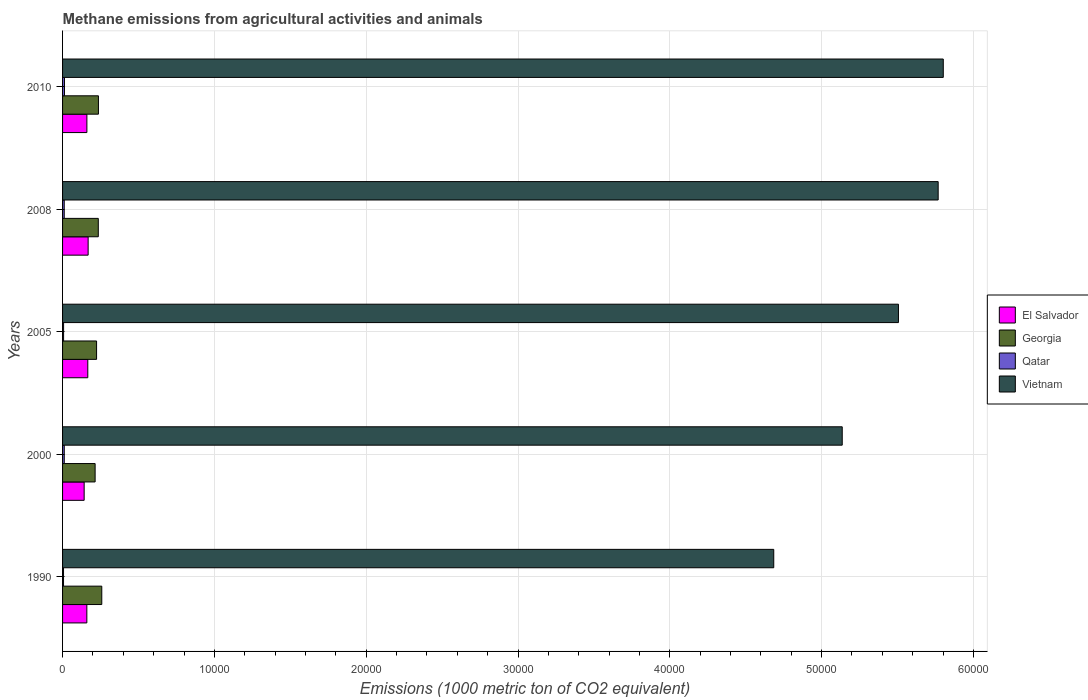Are the number of bars per tick equal to the number of legend labels?
Provide a succinct answer. Yes. In how many cases, is the number of bars for a given year not equal to the number of legend labels?
Provide a short and direct response. 0. What is the amount of methane emitted in Vietnam in 2005?
Provide a succinct answer. 5.51e+04. Across all years, what is the maximum amount of methane emitted in El Salvador?
Keep it short and to the point. 1684.6. Across all years, what is the minimum amount of methane emitted in El Salvador?
Your answer should be very brief. 1421.9. What is the total amount of methane emitted in Georgia in the graph?
Offer a terse response. 1.17e+04. What is the difference between the amount of methane emitted in El Salvador in 2005 and that in 2010?
Give a very brief answer. 60.1. What is the difference between the amount of methane emitted in Vietnam in 1990 and the amount of methane emitted in El Salvador in 2008?
Offer a very short reply. 4.52e+04. What is the average amount of methane emitted in Vietnam per year?
Provide a short and direct response. 5.38e+04. In the year 2008, what is the difference between the amount of methane emitted in Vietnam and amount of methane emitted in El Salvador?
Keep it short and to the point. 5.60e+04. In how many years, is the amount of methane emitted in Georgia greater than 24000 1000 metric ton?
Offer a terse response. 0. What is the ratio of the amount of methane emitted in Georgia in 2005 to that in 2008?
Keep it short and to the point. 0.95. What is the difference between the highest and the second highest amount of methane emitted in El Salvador?
Provide a short and direct response. 22.5. What is the difference between the highest and the lowest amount of methane emitted in Qatar?
Your answer should be compact. 62.1. In how many years, is the amount of methane emitted in El Salvador greater than the average amount of methane emitted in El Salvador taken over all years?
Ensure brevity in your answer.  4. Is the sum of the amount of methane emitted in Vietnam in 1990 and 2000 greater than the maximum amount of methane emitted in El Salvador across all years?
Offer a terse response. Yes. What does the 4th bar from the top in 2000 represents?
Make the answer very short. El Salvador. What does the 2nd bar from the bottom in 1990 represents?
Make the answer very short. Georgia. How many bars are there?
Give a very brief answer. 20. How many years are there in the graph?
Provide a short and direct response. 5. What is the difference between two consecutive major ticks on the X-axis?
Offer a very short reply. 10000. Are the values on the major ticks of X-axis written in scientific E-notation?
Make the answer very short. No. Where does the legend appear in the graph?
Provide a succinct answer. Center right. How are the legend labels stacked?
Your answer should be compact. Vertical. What is the title of the graph?
Ensure brevity in your answer.  Methane emissions from agricultural activities and animals. Does "Eritrea" appear as one of the legend labels in the graph?
Your answer should be compact. No. What is the label or title of the X-axis?
Provide a succinct answer. Emissions (1000 metric ton of CO2 equivalent). What is the label or title of the Y-axis?
Offer a terse response. Years. What is the Emissions (1000 metric ton of CO2 equivalent) of El Salvador in 1990?
Your answer should be compact. 1599.5. What is the Emissions (1000 metric ton of CO2 equivalent) in Georgia in 1990?
Your answer should be compact. 2583.7. What is the Emissions (1000 metric ton of CO2 equivalent) of Qatar in 1990?
Your answer should be compact. 63.8. What is the Emissions (1000 metric ton of CO2 equivalent) of Vietnam in 1990?
Your answer should be compact. 4.68e+04. What is the Emissions (1000 metric ton of CO2 equivalent) in El Salvador in 2000?
Give a very brief answer. 1421.9. What is the Emissions (1000 metric ton of CO2 equivalent) in Georgia in 2000?
Your answer should be compact. 2145. What is the Emissions (1000 metric ton of CO2 equivalent) in Qatar in 2000?
Make the answer very short. 111.5. What is the Emissions (1000 metric ton of CO2 equivalent) of Vietnam in 2000?
Ensure brevity in your answer.  5.14e+04. What is the Emissions (1000 metric ton of CO2 equivalent) in El Salvador in 2005?
Your response must be concise. 1662.1. What is the Emissions (1000 metric ton of CO2 equivalent) in Georgia in 2005?
Your response must be concise. 2240.7. What is the Emissions (1000 metric ton of CO2 equivalent) in Qatar in 2005?
Your response must be concise. 67.4. What is the Emissions (1000 metric ton of CO2 equivalent) of Vietnam in 2005?
Your response must be concise. 5.51e+04. What is the Emissions (1000 metric ton of CO2 equivalent) of El Salvador in 2008?
Offer a terse response. 1684.6. What is the Emissions (1000 metric ton of CO2 equivalent) in Georgia in 2008?
Your answer should be compact. 2354. What is the Emissions (1000 metric ton of CO2 equivalent) in Qatar in 2008?
Keep it short and to the point. 110. What is the Emissions (1000 metric ton of CO2 equivalent) of Vietnam in 2008?
Your response must be concise. 5.77e+04. What is the Emissions (1000 metric ton of CO2 equivalent) of El Salvador in 2010?
Your answer should be compact. 1602. What is the Emissions (1000 metric ton of CO2 equivalent) of Georgia in 2010?
Your answer should be compact. 2363.1. What is the Emissions (1000 metric ton of CO2 equivalent) of Qatar in 2010?
Offer a terse response. 125.9. What is the Emissions (1000 metric ton of CO2 equivalent) in Vietnam in 2010?
Your answer should be compact. 5.80e+04. Across all years, what is the maximum Emissions (1000 metric ton of CO2 equivalent) of El Salvador?
Keep it short and to the point. 1684.6. Across all years, what is the maximum Emissions (1000 metric ton of CO2 equivalent) of Georgia?
Your answer should be compact. 2583.7. Across all years, what is the maximum Emissions (1000 metric ton of CO2 equivalent) in Qatar?
Offer a very short reply. 125.9. Across all years, what is the maximum Emissions (1000 metric ton of CO2 equivalent) in Vietnam?
Make the answer very short. 5.80e+04. Across all years, what is the minimum Emissions (1000 metric ton of CO2 equivalent) of El Salvador?
Ensure brevity in your answer.  1421.9. Across all years, what is the minimum Emissions (1000 metric ton of CO2 equivalent) of Georgia?
Provide a short and direct response. 2145. Across all years, what is the minimum Emissions (1000 metric ton of CO2 equivalent) in Qatar?
Keep it short and to the point. 63.8. Across all years, what is the minimum Emissions (1000 metric ton of CO2 equivalent) in Vietnam?
Offer a terse response. 4.68e+04. What is the total Emissions (1000 metric ton of CO2 equivalent) in El Salvador in the graph?
Your answer should be very brief. 7970.1. What is the total Emissions (1000 metric ton of CO2 equivalent) of Georgia in the graph?
Keep it short and to the point. 1.17e+04. What is the total Emissions (1000 metric ton of CO2 equivalent) of Qatar in the graph?
Offer a terse response. 478.6. What is the total Emissions (1000 metric ton of CO2 equivalent) in Vietnam in the graph?
Your answer should be compact. 2.69e+05. What is the difference between the Emissions (1000 metric ton of CO2 equivalent) of El Salvador in 1990 and that in 2000?
Provide a short and direct response. 177.6. What is the difference between the Emissions (1000 metric ton of CO2 equivalent) in Georgia in 1990 and that in 2000?
Provide a succinct answer. 438.7. What is the difference between the Emissions (1000 metric ton of CO2 equivalent) of Qatar in 1990 and that in 2000?
Your answer should be compact. -47.7. What is the difference between the Emissions (1000 metric ton of CO2 equivalent) of Vietnam in 1990 and that in 2000?
Provide a succinct answer. -4511. What is the difference between the Emissions (1000 metric ton of CO2 equivalent) in El Salvador in 1990 and that in 2005?
Your response must be concise. -62.6. What is the difference between the Emissions (1000 metric ton of CO2 equivalent) in Georgia in 1990 and that in 2005?
Make the answer very short. 343. What is the difference between the Emissions (1000 metric ton of CO2 equivalent) in Qatar in 1990 and that in 2005?
Provide a succinct answer. -3.6. What is the difference between the Emissions (1000 metric ton of CO2 equivalent) in Vietnam in 1990 and that in 2005?
Make the answer very short. -8213.9. What is the difference between the Emissions (1000 metric ton of CO2 equivalent) in El Salvador in 1990 and that in 2008?
Ensure brevity in your answer.  -85.1. What is the difference between the Emissions (1000 metric ton of CO2 equivalent) of Georgia in 1990 and that in 2008?
Your response must be concise. 229.7. What is the difference between the Emissions (1000 metric ton of CO2 equivalent) in Qatar in 1990 and that in 2008?
Offer a terse response. -46.2. What is the difference between the Emissions (1000 metric ton of CO2 equivalent) of Vietnam in 1990 and that in 2008?
Ensure brevity in your answer.  -1.08e+04. What is the difference between the Emissions (1000 metric ton of CO2 equivalent) in Georgia in 1990 and that in 2010?
Offer a terse response. 220.6. What is the difference between the Emissions (1000 metric ton of CO2 equivalent) of Qatar in 1990 and that in 2010?
Provide a succinct answer. -62.1. What is the difference between the Emissions (1000 metric ton of CO2 equivalent) of Vietnam in 1990 and that in 2010?
Your answer should be compact. -1.12e+04. What is the difference between the Emissions (1000 metric ton of CO2 equivalent) of El Salvador in 2000 and that in 2005?
Your answer should be compact. -240.2. What is the difference between the Emissions (1000 metric ton of CO2 equivalent) of Georgia in 2000 and that in 2005?
Give a very brief answer. -95.7. What is the difference between the Emissions (1000 metric ton of CO2 equivalent) of Qatar in 2000 and that in 2005?
Give a very brief answer. 44.1. What is the difference between the Emissions (1000 metric ton of CO2 equivalent) in Vietnam in 2000 and that in 2005?
Your answer should be very brief. -3702.9. What is the difference between the Emissions (1000 metric ton of CO2 equivalent) in El Salvador in 2000 and that in 2008?
Your answer should be compact. -262.7. What is the difference between the Emissions (1000 metric ton of CO2 equivalent) in Georgia in 2000 and that in 2008?
Make the answer very short. -209. What is the difference between the Emissions (1000 metric ton of CO2 equivalent) of Qatar in 2000 and that in 2008?
Your answer should be compact. 1.5. What is the difference between the Emissions (1000 metric ton of CO2 equivalent) in Vietnam in 2000 and that in 2008?
Keep it short and to the point. -6319.4. What is the difference between the Emissions (1000 metric ton of CO2 equivalent) of El Salvador in 2000 and that in 2010?
Provide a succinct answer. -180.1. What is the difference between the Emissions (1000 metric ton of CO2 equivalent) in Georgia in 2000 and that in 2010?
Offer a terse response. -218.1. What is the difference between the Emissions (1000 metric ton of CO2 equivalent) of Qatar in 2000 and that in 2010?
Ensure brevity in your answer.  -14.4. What is the difference between the Emissions (1000 metric ton of CO2 equivalent) in Vietnam in 2000 and that in 2010?
Give a very brief answer. -6656.2. What is the difference between the Emissions (1000 metric ton of CO2 equivalent) in El Salvador in 2005 and that in 2008?
Offer a very short reply. -22.5. What is the difference between the Emissions (1000 metric ton of CO2 equivalent) of Georgia in 2005 and that in 2008?
Offer a very short reply. -113.3. What is the difference between the Emissions (1000 metric ton of CO2 equivalent) of Qatar in 2005 and that in 2008?
Give a very brief answer. -42.6. What is the difference between the Emissions (1000 metric ton of CO2 equivalent) in Vietnam in 2005 and that in 2008?
Offer a terse response. -2616.5. What is the difference between the Emissions (1000 metric ton of CO2 equivalent) in El Salvador in 2005 and that in 2010?
Make the answer very short. 60.1. What is the difference between the Emissions (1000 metric ton of CO2 equivalent) in Georgia in 2005 and that in 2010?
Ensure brevity in your answer.  -122.4. What is the difference between the Emissions (1000 metric ton of CO2 equivalent) in Qatar in 2005 and that in 2010?
Keep it short and to the point. -58.5. What is the difference between the Emissions (1000 metric ton of CO2 equivalent) in Vietnam in 2005 and that in 2010?
Make the answer very short. -2953.3. What is the difference between the Emissions (1000 metric ton of CO2 equivalent) in El Salvador in 2008 and that in 2010?
Offer a terse response. 82.6. What is the difference between the Emissions (1000 metric ton of CO2 equivalent) of Georgia in 2008 and that in 2010?
Offer a terse response. -9.1. What is the difference between the Emissions (1000 metric ton of CO2 equivalent) of Qatar in 2008 and that in 2010?
Provide a succinct answer. -15.9. What is the difference between the Emissions (1000 metric ton of CO2 equivalent) in Vietnam in 2008 and that in 2010?
Your answer should be compact. -336.8. What is the difference between the Emissions (1000 metric ton of CO2 equivalent) of El Salvador in 1990 and the Emissions (1000 metric ton of CO2 equivalent) of Georgia in 2000?
Offer a terse response. -545.5. What is the difference between the Emissions (1000 metric ton of CO2 equivalent) of El Salvador in 1990 and the Emissions (1000 metric ton of CO2 equivalent) of Qatar in 2000?
Your answer should be compact. 1488. What is the difference between the Emissions (1000 metric ton of CO2 equivalent) of El Salvador in 1990 and the Emissions (1000 metric ton of CO2 equivalent) of Vietnam in 2000?
Ensure brevity in your answer.  -4.98e+04. What is the difference between the Emissions (1000 metric ton of CO2 equivalent) of Georgia in 1990 and the Emissions (1000 metric ton of CO2 equivalent) of Qatar in 2000?
Keep it short and to the point. 2472.2. What is the difference between the Emissions (1000 metric ton of CO2 equivalent) of Georgia in 1990 and the Emissions (1000 metric ton of CO2 equivalent) of Vietnam in 2000?
Offer a very short reply. -4.88e+04. What is the difference between the Emissions (1000 metric ton of CO2 equivalent) in Qatar in 1990 and the Emissions (1000 metric ton of CO2 equivalent) in Vietnam in 2000?
Your response must be concise. -5.13e+04. What is the difference between the Emissions (1000 metric ton of CO2 equivalent) of El Salvador in 1990 and the Emissions (1000 metric ton of CO2 equivalent) of Georgia in 2005?
Offer a very short reply. -641.2. What is the difference between the Emissions (1000 metric ton of CO2 equivalent) in El Salvador in 1990 and the Emissions (1000 metric ton of CO2 equivalent) in Qatar in 2005?
Offer a terse response. 1532.1. What is the difference between the Emissions (1000 metric ton of CO2 equivalent) in El Salvador in 1990 and the Emissions (1000 metric ton of CO2 equivalent) in Vietnam in 2005?
Offer a very short reply. -5.35e+04. What is the difference between the Emissions (1000 metric ton of CO2 equivalent) of Georgia in 1990 and the Emissions (1000 metric ton of CO2 equivalent) of Qatar in 2005?
Ensure brevity in your answer.  2516.3. What is the difference between the Emissions (1000 metric ton of CO2 equivalent) in Georgia in 1990 and the Emissions (1000 metric ton of CO2 equivalent) in Vietnam in 2005?
Provide a short and direct response. -5.25e+04. What is the difference between the Emissions (1000 metric ton of CO2 equivalent) in Qatar in 1990 and the Emissions (1000 metric ton of CO2 equivalent) in Vietnam in 2005?
Provide a succinct answer. -5.50e+04. What is the difference between the Emissions (1000 metric ton of CO2 equivalent) of El Salvador in 1990 and the Emissions (1000 metric ton of CO2 equivalent) of Georgia in 2008?
Your response must be concise. -754.5. What is the difference between the Emissions (1000 metric ton of CO2 equivalent) in El Salvador in 1990 and the Emissions (1000 metric ton of CO2 equivalent) in Qatar in 2008?
Offer a very short reply. 1489.5. What is the difference between the Emissions (1000 metric ton of CO2 equivalent) in El Salvador in 1990 and the Emissions (1000 metric ton of CO2 equivalent) in Vietnam in 2008?
Make the answer very short. -5.61e+04. What is the difference between the Emissions (1000 metric ton of CO2 equivalent) of Georgia in 1990 and the Emissions (1000 metric ton of CO2 equivalent) of Qatar in 2008?
Offer a terse response. 2473.7. What is the difference between the Emissions (1000 metric ton of CO2 equivalent) in Georgia in 1990 and the Emissions (1000 metric ton of CO2 equivalent) in Vietnam in 2008?
Make the answer very short. -5.51e+04. What is the difference between the Emissions (1000 metric ton of CO2 equivalent) of Qatar in 1990 and the Emissions (1000 metric ton of CO2 equivalent) of Vietnam in 2008?
Make the answer very short. -5.76e+04. What is the difference between the Emissions (1000 metric ton of CO2 equivalent) in El Salvador in 1990 and the Emissions (1000 metric ton of CO2 equivalent) in Georgia in 2010?
Make the answer very short. -763.6. What is the difference between the Emissions (1000 metric ton of CO2 equivalent) of El Salvador in 1990 and the Emissions (1000 metric ton of CO2 equivalent) of Qatar in 2010?
Ensure brevity in your answer.  1473.6. What is the difference between the Emissions (1000 metric ton of CO2 equivalent) in El Salvador in 1990 and the Emissions (1000 metric ton of CO2 equivalent) in Vietnam in 2010?
Make the answer very short. -5.64e+04. What is the difference between the Emissions (1000 metric ton of CO2 equivalent) of Georgia in 1990 and the Emissions (1000 metric ton of CO2 equivalent) of Qatar in 2010?
Ensure brevity in your answer.  2457.8. What is the difference between the Emissions (1000 metric ton of CO2 equivalent) in Georgia in 1990 and the Emissions (1000 metric ton of CO2 equivalent) in Vietnam in 2010?
Provide a succinct answer. -5.54e+04. What is the difference between the Emissions (1000 metric ton of CO2 equivalent) in Qatar in 1990 and the Emissions (1000 metric ton of CO2 equivalent) in Vietnam in 2010?
Provide a succinct answer. -5.80e+04. What is the difference between the Emissions (1000 metric ton of CO2 equivalent) in El Salvador in 2000 and the Emissions (1000 metric ton of CO2 equivalent) in Georgia in 2005?
Offer a terse response. -818.8. What is the difference between the Emissions (1000 metric ton of CO2 equivalent) of El Salvador in 2000 and the Emissions (1000 metric ton of CO2 equivalent) of Qatar in 2005?
Give a very brief answer. 1354.5. What is the difference between the Emissions (1000 metric ton of CO2 equivalent) in El Salvador in 2000 and the Emissions (1000 metric ton of CO2 equivalent) in Vietnam in 2005?
Offer a terse response. -5.36e+04. What is the difference between the Emissions (1000 metric ton of CO2 equivalent) in Georgia in 2000 and the Emissions (1000 metric ton of CO2 equivalent) in Qatar in 2005?
Give a very brief answer. 2077.6. What is the difference between the Emissions (1000 metric ton of CO2 equivalent) in Georgia in 2000 and the Emissions (1000 metric ton of CO2 equivalent) in Vietnam in 2005?
Provide a short and direct response. -5.29e+04. What is the difference between the Emissions (1000 metric ton of CO2 equivalent) of Qatar in 2000 and the Emissions (1000 metric ton of CO2 equivalent) of Vietnam in 2005?
Provide a short and direct response. -5.50e+04. What is the difference between the Emissions (1000 metric ton of CO2 equivalent) in El Salvador in 2000 and the Emissions (1000 metric ton of CO2 equivalent) in Georgia in 2008?
Keep it short and to the point. -932.1. What is the difference between the Emissions (1000 metric ton of CO2 equivalent) of El Salvador in 2000 and the Emissions (1000 metric ton of CO2 equivalent) of Qatar in 2008?
Your answer should be compact. 1311.9. What is the difference between the Emissions (1000 metric ton of CO2 equivalent) in El Salvador in 2000 and the Emissions (1000 metric ton of CO2 equivalent) in Vietnam in 2008?
Provide a short and direct response. -5.63e+04. What is the difference between the Emissions (1000 metric ton of CO2 equivalent) in Georgia in 2000 and the Emissions (1000 metric ton of CO2 equivalent) in Qatar in 2008?
Give a very brief answer. 2035. What is the difference between the Emissions (1000 metric ton of CO2 equivalent) in Georgia in 2000 and the Emissions (1000 metric ton of CO2 equivalent) in Vietnam in 2008?
Offer a very short reply. -5.55e+04. What is the difference between the Emissions (1000 metric ton of CO2 equivalent) in Qatar in 2000 and the Emissions (1000 metric ton of CO2 equivalent) in Vietnam in 2008?
Give a very brief answer. -5.76e+04. What is the difference between the Emissions (1000 metric ton of CO2 equivalent) of El Salvador in 2000 and the Emissions (1000 metric ton of CO2 equivalent) of Georgia in 2010?
Your answer should be compact. -941.2. What is the difference between the Emissions (1000 metric ton of CO2 equivalent) in El Salvador in 2000 and the Emissions (1000 metric ton of CO2 equivalent) in Qatar in 2010?
Offer a terse response. 1296. What is the difference between the Emissions (1000 metric ton of CO2 equivalent) in El Salvador in 2000 and the Emissions (1000 metric ton of CO2 equivalent) in Vietnam in 2010?
Ensure brevity in your answer.  -5.66e+04. What is the difference between the Emissions (1000 metric ton of CO2 equivalent) of Georgia in 2000 and the Emissions (1000 metric ton of CO2 equivalent) of Qatar in 2010?
Your answer should be very brief. 2019.1. What is the difference between the Emissions (1000 metric ton of CO2 equivalent) in Georgia in 2000 and the Emissions (1000 metric ton of CO2 equivalent) in Vietnam in 2010?
Provide a short and direct response. -5.59e+04. What is the difference between the Emissions (1000 metric ton of CO2 equivalent) in Qatar in 2000 and the Emissions (1000 metric ton of CO2 equivalent) in Vietnam in 2010?
Make the answer very short. -5.79e+04. What is the difference between the Emissions (1000 metric ton of CO2 equivalent) of El Salvador in 2005 and the Emissions (1000 metric ton of CO2 equivalent) of Georgia in 2008?
Provide a succinct answer. -691.9. What is the difference between the Emissions (1000 metric ton of CO2 equivalent) of El Salvador in 2005 and the Emissions (1000 metric ton of CO2 equivalent) of Qatar in 2008?
Keep it short and to the point. 1552.1. What is the difference between the Emissions (1000 metric ton of CO2 equivalent) of El Salvador in 2005 and the Emissions (1000 metric ton of CO2 equivalent) of Vietnam in 2008?
Your response must be concise. -5.60e+04. What is the difference between the Emissions (1000 metric ton of CO2 equivalent) in Georgia in 2005 and the Emissions (1000 metric ton of CO2 equivalent) in Qatar in 2008?
Keep it short and to the point. 2130.7. What is the difference between the Emissions (1000 metric ton of CO2 equivalent) in Georgia in 2005 and the Emissions (1000 metric ton of CO2 equivalent) in Vietnam in 2008?
Offer a very short reply. -5.54e+04. What is the difference between the Emissions (1000 metric ton of CO2 equivalent) of Qatar in 2005 and the Emissions (1000 metric ton of CO2 equivalent) of Vietnam in 2008?
Offer a very short reply. -5.76e+04. What is the difference between the Emissions (1000 metric ton of CO2 equivalent) of El Salvador in 2005 and the Emissions (1000 metric ton of CO2 equivalent) of Georgia in 2010?
Offer a terse response. -701. What is the difference between the Emissions (1000 metric ton of CO2 equivalent) of El Salvador in 2005 and the Emissions (1000 metric ton of CO2 equivalent) of Qatar in 2010?
Your answer should be very brief. 1536.2. What is the difference between the Emissions (1000 metric ton of CO2 equivalent) of El Salvador in 2005 and the Emissions (1000 metric ton of CO2 equivalent) of Vietnam in 2010?
Offer a very short reply. -5.64e+04. What is the difference between the Emissions (1000 metric ton of CO2 equivalent) in Georgia in 2005 and the Emissions (1000 metric ton of CO2 equivalent) in Qatar in 2010?
Give a very brief answer. 2114.8. What is the difference between the Emissions (1000 metric ton of CO2 equivalent) of Georgia in 2005 and the Emissions (1000 metric ton of CO2 equivalent) of Vietnam in 2010?
Your answer should be compact. -5.58e+04. What is the difference between the Emissions (1000 metric ton of CO2 equivalent) in Qatar in 2005 and the Emissions (1000 metric ton of CO2 equivalent) in Vietnam in 2010?
Offer a terse response. -5.79e+04. What is the difference between the Emissions (1000 metric ton of CO2 equivalent) of El Salvador in 2008 and the Emissions (1000 metric ton of CO2 equivalent) of Georgia in 2010?
Make the answer very short. -678.5. What is the difference between the Emissions (1000 metric ton of CO2 equivalent) in El Salvador in 2008 and the Emissions (1000 metric ton of CO2 equivalent) in Qatar in 2010?
Give a very brief answer. 1558.7. What is the difference between the Emissions (1000 metric ton of CO2 equivalent) in El Salvador in 2008 and the Emissions (1000 metric ton of CO2 equivalent) in Vietnam in 2010?
Your response must be concise. -5.63e+04. What is the difference between the Emissions (1000 metric ton of CO2 equivalent) of Georgia in 2008 and the Emissions (1000 metric ton of CO2 equivalent) of Qatar in 2010?
Your response must be concise. 2228.1. What is the difference between the Emissions (1000 metric ton of CO2 equivalent) of Georgia in 2008 and the Emissions (1000 metric ton of CO2 equivalent) of Vietnam in 2010?
Give a very brief answer. -5.57e+04. What is the difference between the Emissions (1000 metric ton of CO2 equivalent) of Qatar in 2008 and the Emissions (1000 metric ton of CO2 equivalent) of Vietnam in 2010?
Your answer should be compact. -5.79e+04. What is the average Emissions (1000 metric ton of CO2 equivalent) in El Salvador per year?
Provide a succinct answer. 1594.02. What is the average Emissions (1000 metric ton of CO2 equivalent) of Georgia per year?
Make the answer very short. 2337.3. What is the average Emissions (1000 metric ton of CO2 equivalent) of Qatar per year?
Offer a very short reply. 95.72. What is the average Emissions (1000 metric ton of CO2 equivalent) of Vietnam per year?
Ensure brevity in your answer.  5.38e+04. In the year 1990, what is the difference between the Emissions (1000 metric ton of CO2 equivalent) of El Salvador and Emissions (1000 metric ton of CO2 equivalent) of Georgia?
Offer a very short reply. -984.2. In the year 1990, what is the difference between the Emissions (1000 metric ton of CO2 equivalent) in El Salvador and Emissions (1000 metric ton of CO2 equivalent) in Qatar?
Keep it short and to the point. 1535.7. In the year 1990, what is the difference between the Emissions (1000 metric ton of CO2 equivalent) of El Salvador and Emissions (1000 metric ton of CO2 equivalent) of Vietnam?
Give a very brief answer. -4.52e+04. In the year 1990, what is the difference between the Emissions (1000 metric ton of CO2 equivalent) in Georgia and Emissions (1000 metric ton of CO2 equivalent) in Qatar?
Make the answer very short. 2519.9. In the year 1990, what is the difference between the Emissions (1000 metric ton of CO2 equivalent) in Georgia and Emissions (1000 metric ton of CO2 equivalent) in Vietnam?
Provide a short and direct response. -4.43e+04. In the year 1990, what is the difference between the Emissions (1000 metric ton of CO2 equivalent) of Qatar and Emissions (1000 metric ton of CO2 equivalent) of Vietnam?
Your response must be concise. -4.68e+04. In the year 2000, what is the difference between the Emissions (1000 metric ton of CO2 equivalent) of El Salvador and Emissions (1000 metric ton of CO2 equivalent) of Georgia?
Offer a very short reply. -723.1. In the year 2000, what is the difference between the Emissions (1000 metric ton of CO2 equivalent) in El Salvador and Emissions (1000 metric ton of CO2 equivalent) in Qatar?
Offer a terse response. 1310.4. In the year 2000, what is the difference between the Emissions (1000 metric ton of CO2 equivalent) of El Salvador and Emissions (1000 metric ton of CO2 equivalent) of Vietnam?
Provide a short and direct response. -4.99e+04. In the year 2000, what is the difference between the Emissions (1000 metric ton of CO2 equivalent) in Georgia and Emissions (1000 metric ton of CO2 equivalent) in Qatar?
Keep it short and to the point. 2033.5. In the year 2000, what is the difference between the Emissions (1000 metric ton of CO2 equivalent) in Georgia and Emissions (1000 metric ton of CO2 equivalent) in Vietnam?
Provide a succinct answer. -4.92e+04. In the year 2000, what is the difference between the Emissions (1000 metric ton of CO2 equivalent) of Qatar and Emissions (1000 metric ton of CO2 equivalent) of Vietnam?
Your response must be concise. -5.12e+04. In the year 2005, what is the difference between the Emissions (1000 metric ton of CO2 equivalent) in El Salvador and Emissions (1000 metric ton of CO2 equivalent) in Georgia?
Provide a succinct answer. -578.6. In the year 2005, what is the difference between the Emissions (1000 metric ton of CO2 equivalent) in El Salvador and Emissions (1000 metric ton of CO2 equivalent) in Qatar?
Provide a succinct answer. 1594.7. In the year 2005, what is the difference between the Emissions (1000 metric ton of CO2 equivalent) in El Salvador and Emissions (1000 metric ton of CO2 equivalent) in Vietnam?
Offer a terse response. -5.34e+04. In the year 2005, what is the difference between the Emissions (1000 metric ton of CO2 equivalent) of Georgia and Emissions (1000 metric ton of CO2 equivalent) of Qatar?
Provide a succinct answer. 2173.3. In the year 2005, what is the difference between the Emissions (1000 metric ton of CO2 equivalent) of Georgia and Emissions (1000 metric ton of CO2 equivalent) of Vietnam?
Ensure brevity in your answer.  -5.28e+04. In the year 2005, what is the difference between the Emissions (1000 metric ton of CO2 equivalent) in Qatar and Emissions (1000 metric ton of CO2 equivalent) in Vietnam?
Provide a short and direct response. -5.50e+04. In the year 2008, what is the difference between the Emissions (1000 metric ton of CO2 equivalent) in El Salvador and Emissions (1000 metric ton of CO2 equivalent) in Georgia?
Your answer should be very brief. -669.4. In the year 2008, what is the difference between the Emissions (1000 metric ton of CO2 equivalent) in El Salvador and Emissions (1000 metric ton of CO2 equivalent) in Qatar?
Keep it short and to the point. 1574.6. In the year 2008, what is the difference between the Emissions (1000 metric ton of CO2 equivalent) in El Salvador and Emissions (1000 metric ton of CO2 equivalent) in Vietnam?
Your response must be concise. -5.60e+04. In the year 2008, what is the difference between the Emissions (1000 metric ton of CO2 equivalent) in Georgia and Emissions (1000 metric ton of CO2 equivalent) in Qatar?
Keep it short and to the point. 2244. In the year 2008, what is the difference between the Emissions (1000 metric ton of CO2 equivalent) in Georgia and Emissions (1000 metric ton of CO2 equivalent) in Vietnam?
Your answer should be very brief. -5.53e+04. In the year 2008, what is the difference between the Emissions (1000 metric ton of CO2 equivalent) of Qatar and Emissions (1000 metric ton of CO2 equivalent) of Vietnam?
Ensure brevity in your answer.  -5.76e+04. In the year 2010, what is the difference between the Emissions (1000 metric ton of CO2 equivalent) of El Salvador and Emissions (1000 metric ton of CO2 equivalent) of Georgia?
Give a very brief answer. -761.1. In the year 2010, what is the difference between the Emissions (1000 metric ton of CO2 equivalent) in El Salvador and Emissions (1000 metric ton of CO2 equivalent) in Qatar?
Your answer should be very brief. 1476.1. In the year 2010, what is the difference between the Emissions (1000 metric ton of CO2 equivalent) in El Salvador and Emissions (1000 metric ton of CO2 equivalent) in Vietnam?
Your answer should be compact. -5.64e+04. In the year 2010, what is the difference between the Emissions (1000 metric ton of CO2 equivalent) in Georgia and Emissions (1000 metric ton of CO2 equivalent) in Qatar?
Ensure brevity in your answer.  2237.2. In the year 2010, what is the difference between the Emissions (1000 metric ton of CO2 equivalent) of Georgia and Emissions (1000 metric ton of CO2 equivalent) of Vietnam?
Your response must be concise. -5.57e+04. In the year 2010, what is the difference between the Emissions (1000 metric ton of CO2 equivalent) in Qatar and Emissions (1000 metric ton of CO2 equivalent) in Vietnam?
Give a very brief answer. -5.79e+04. What is the ratio of the Emissions (1000 metric ton of CO2 equivalent) in El Salvador in 1990 to that in 2000?
Keep it short and to the point. 1.12. What is the ratio of the Emissions (1000 metric ton of CO2 equivalent) in Georgia in 1990 to that in 2000?
Keep it short and to the point. 1.2. What is the ratio of the Emissions (1000 metric ton of CO2 equivalent) of Qatar in 1990 to that in 2000?
Your answer should be compact. 0.57. What is the ratio of the Emissions (1000 metric ton of CO2 equivalent) of Vietnam in 1990 to that in 2000?
Give a very brief answer. 0.91. What is the ratio of the Emissions (1000 metric ton of CO2 equivalent) in El Salvador in 1990 to that in 2005?
Your response must be concise. 0.96. What is the ratio of the Emissions (1000 metric ton of CO2 equivalent) in Georgia in 1990 to that in 2005?
Provide a short and direct response. 1.15. What is the ratio of the Emissions (1000 metric ton of CO2 equivalent) in Qatar in 1990 to that in 2005?
Provide a short and direct response. 0.95. What is the ratio of the Emissions (1000 metric ton of CO2 equivalent) in Vietnam in 1990 to that in 2005?
Give a very brief answer. 0.85. What is the ratio of the Emissions (1000 metric ton of CO2 equivalent) of El Salvador in 1990 to that in 2008?
Keep it short and to the point. 0.95. What is the ratio of the Emissions (1000 metric ton of CO2 equivalent) in Georgia in 1990 to that in 2008?
Provide a short and direct response. 1.1. What is the ratio of the Emissions (1000 metric ton of CO2 equivalent) of Qatar in 1990 to that in 2008?
Provide a short and direct response. 0.58. What is the ratio of the Emissions (1000 metric ton of CO2 equivalent) of Vietnam in 1990 to that in 2008?
Offer a very short reply. 0.81. What is the ratio of the Emissions (1000 metric ton of CO2 equivalent) in El Salvador in 1990 to that in 2010?
Provide a succinct answer. 1. What is the ratio of the Emissions (1000 metric ton of CO2 equivalent) in Georgia in 1990 to that in 2010?
Make the answer very short. 1.09. What is the ratio of the Emissions (1000 metric ton of CO2 equivalent) of Qatar in 1990 to that in 2010?
Provide a short and direct response. 0.51. What is the ratio of the Emissions (1000 metric ton of CO2 equivalent) in Vietnam in 1990 to that in 2010?
Keep it short and to the point. 0.81. What is the ratio of the Emissions (1000 metric ton of CO2 equivalent) in El Salvador in 2000 to that in 2005?
Give a very brief answer. 0.86. What is the ratio of the Emissions (1000 metric ton of CO2 equivalent) in Georgia in 2000 to that in 2005?
Ensure brevity in your answer.  0.96. What is the ratio of the Emissions (1000 metric ton of CO2 equivalent) in Qatar in 2000 to that in 2005?
Offer a terse response. 1.65. What is the ratio of the Emissions (1000 metric ton of CO2 equivalent) of Vietnam in 2000 to that in 2005?
Ensure brevity in your answer.  0.93. What is the ratio of the Emissions (1000 metric ton of CO2 equivalent) of El Salvador in 2000 to that in 2008?
Provide a short and direct response. 0.84. What is the ratio of the Emissions (1000 metric ton of CO2 equivalent) in Georgia in 2000 to that in 2008?
Provide a short and direct response. 0.91. What is the ratio of the Emissions (1000 metric ton of CO2 equivalent) of Qatar in 2000 to that in 2008?
Provide a succinct answer. 1.01. What is the ratio of the Emissions (1000 metric ton of CO2 equivalent) in Vietnam in 2000 to that in 2008?
Provide a short and direct response. 0.89. What is the ratio of the Emissions (1000 metric ton of CO2 equivalent) of El Salvador in 2000 to that in 2010?
Your answer should be very brief. 0.89. What is the ratio of the Emissions (1000 metric ton of CO2 equivalent) in Georgia in 2000 to that in 2010?
Provide a short and direct response. 0.91. What is the ratio of the Emissions (1000 metric ton of CO2 equivalent) of Qatar in 2000 to that in 2010?
Make the answer very short. 0.89. What is the ratio of the Emissions (1000 metric ton of CO2 equivalent) of Vietnam in 2000 to that in 2010?
Offer a terse response. 0.89. What is the ratio of the Emissions (1000 metric ton of CO2 equivalent) in El Salvador in 2005 to that in 2008?
Give a very brief answer. 0.99. What is the ratio of the Emissions (1000 metric ton of CO2 equivalent) of Georgia in 2005 to that in 2008?
Make the answer very short. 0.95. What is the ratio of the Emissions (1000 metric ton of CO2 equivalent) of Qatar in 2005 to that in 2008?
Your answer should be compact. 0.61. What is the ratio of the Emissions (1000 metric ton of CO2 equivalent) of Vietnam in 2005 to that in 2008?
Your response must be concise. 0.95. What is the ratio of the Emissions (1000 metric ton of CO2 equivalent) in El Salvador in 2005 to that in 2010?
Your response must be concise. 1.04. What is the ratio of the Emissions (1000 metric ton of CO2 equivalent) in Georgia in 2005 to that in 2010?
Make the answer very short. 0.95. What is the ratio of the Emissions (1000 metric ton of CO2 equivalent) of Qatar in 2005 to that in 2010?
Offer a terse response. 0.54. What is the ratio of the Emissions (1000 metric ton of CO2 equivalent) in Vietnam in 2005 to that in 2010?
Provide a short and direct response. 0.95. What is the ratio of the Emissions (1000 metric ton of CO2 equivalent) in El Salvador in 2008 to that in 2010?
Provide a short and direct response. 1.05. What is the ratio of the Emissions (1000 metric ton of CO2 equivalent) of Georgia in 2008 to that in 2010?
Your answer should be compact. 1. What is the ratio of the Emissions (1000 metric ton of CO2 equivalent) in Qatar in 2008 to that in 2010?
Offer a terse response. 0.87. What is the ratio of the Emissions (1000 metric ton of CO2 equivalent) in Vietnam in 2008 to that in 2010?
Keep it short and to the point. 0.99. What is the difference between the highest and the second highest Emissions (1000 metric ton of CO2 equivalent) in El Salvador?
Ensure brevity in your answer.  22.5. What is the difference between the highest and the second highest Emissions (1000 metric ton of CO2 equivalent) of Georgia?
Provide a short and direct response. 220.6. What is the difference between the highest and the second highest Emissions (1000 metric ton of CO2 equivalent) of Vietnam?
Make the answer very short. 336.8. What is the difference between the highest and the lowest Emissions (1000 metric ton of CO2 equivalent) in El Salvador?
Offer a very short reply. 262.7. What is the difference between the highest and the lowest Emissions (1000 metric ton of CO2 equivalent) of Georgia?
Your answer should be very brief. 438.7. What is the difference between the highest and the lowest Emissions (1000 metric ton of CO2 equivalent) in Qatar?
Ensure brevity in your answer.  62.1. What is the difference between the highest and the lowest Emissions (1000 metric ton of CO2 equivalent) of Vietnam?
Your answer should be compact. 1.12e+04. 